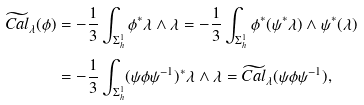<formula> <loc_0><loc_0><loc_500><loc_500>\widetilde { C a l } _ { \lambda } ( \phi ) & = - \frac { 1 } { 3 } \int _ { \Sigma _ { h } ^ { 1 } } \phi ^ { * } \lambda \wedge \lambda = - \frac { 1 } { 3 } \int _ { \Sigma _ { h } ^ { 1 } } \phi ^ { * } ( \psi ^ { * } \lambda ) \wedge \psi ^ { * } ( \lambda ) \\ & = - \frac { 1 } { 3 } \int _ { \Sigma _ { h } ^ { 1 } } ( \psi \phi \psi ^ { - 1 } ) ^ { * } \lambda \wedge \lambda = \widetilde { C a l } _ { \lambda } ( \psi \phi \psi ^ { - 1 } ) ,</formula> 